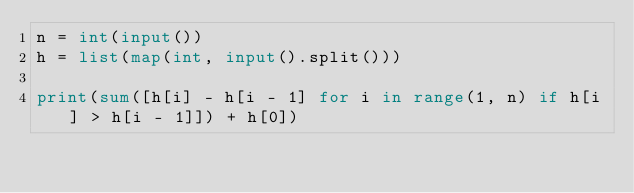<code> <loc_0><loc_0><loc_500><loc_500><_Python_>n = int(input())
h = list(map(int, input().split()))

print(sum([h[i] - h[i - 1] for i in range(1, n) if h[i] > h[i - 1]]) + h[0])</code> 